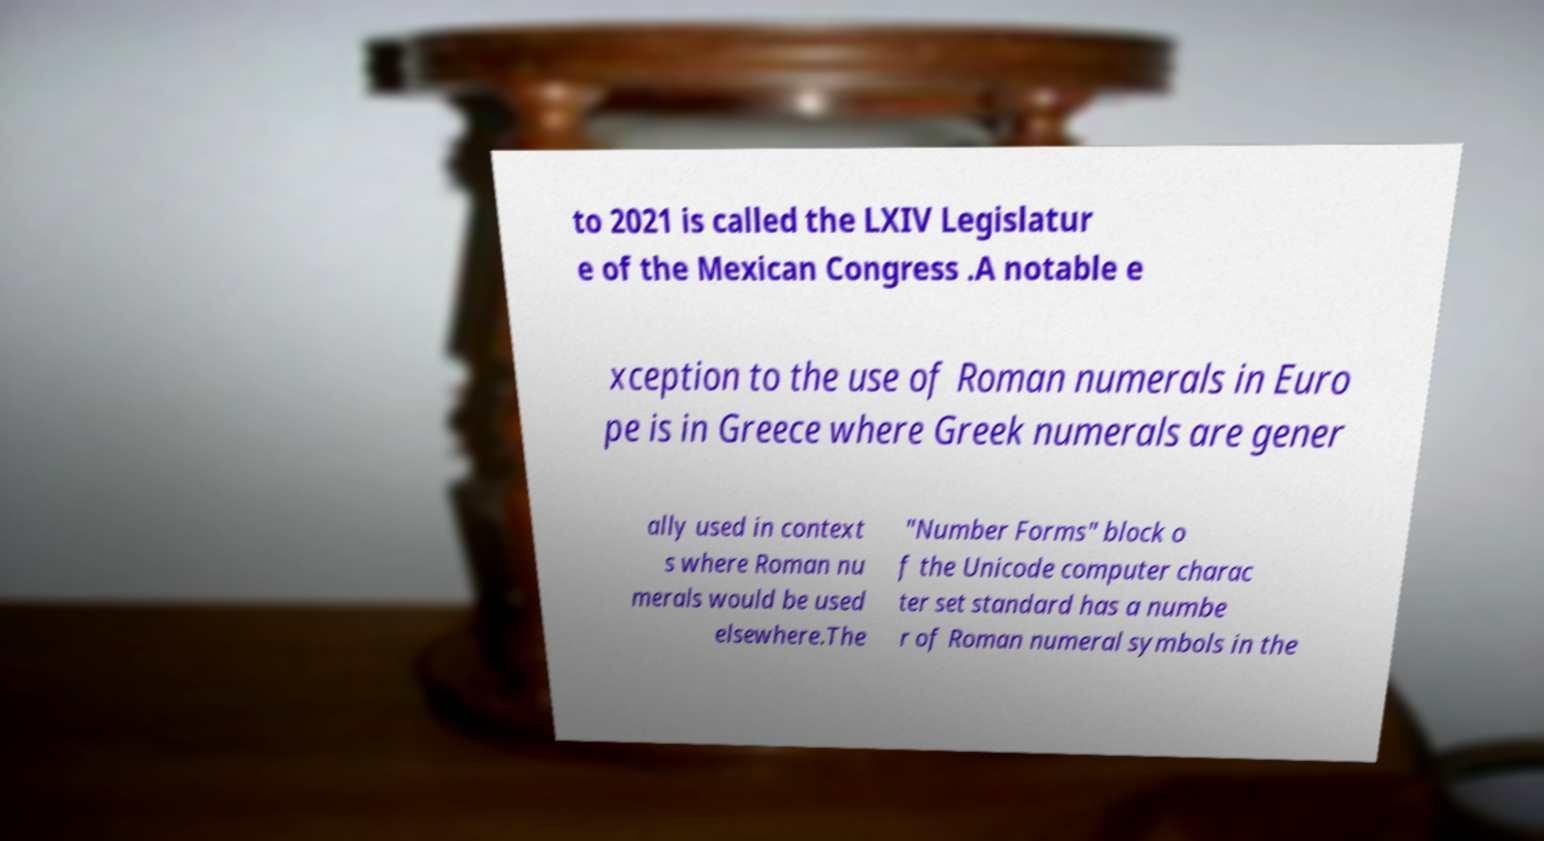Can you read and provide the text displayed in the image?This photo seems to have some interesting text. Can you extract and type it out for me? to 2021 is called the LXIV Legislatur e of the Mexican Congress .A notable e xception to the use of Roman numerals in Euro pe is in Greece where Greek numerals are gener ally used in context s where Roman nu merals would be used elsewhere.The "Number Forms" block o f the Unicode computer charac ter set standard has a numbe r of Roman numeral symbols in the 